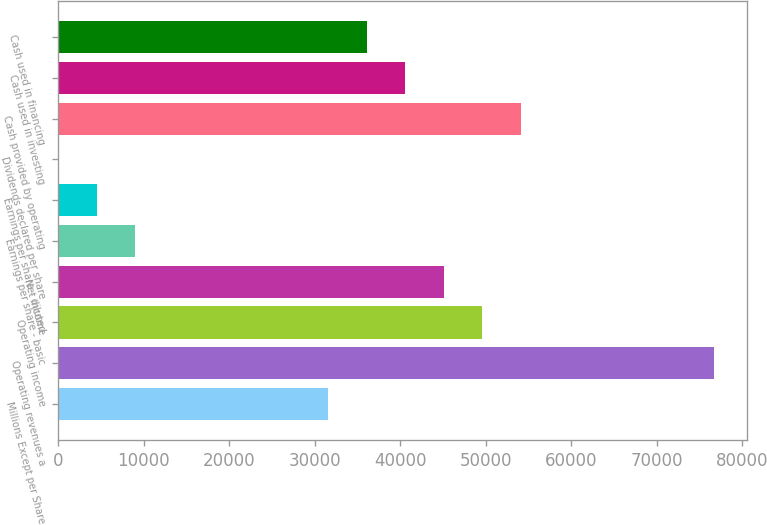Convert chart to OTSL. <chart><loc_0><loc_0><loc_500><loc_500><bar_chart><fcel>Millions Except per Share<fcel>Operating revenues a<fcel>Operating income<fcel>Net income<fcel>Earnings per share - basic<fcel>Earnings per share - diluted<fcel>Dividends declared per share<fcel>Cash provided by operating<fcel>Cash used in investing<fcel>Cash used in financing<nl><fcel>31567.8<fcel>76661.9<fcel>49605.4<fcel>45096<fcel>9020.75<fcel>4511.34<fcel>1.93<fcel>54114.8<fcel>40586.6<fcel>36077.2<nl></chart> 